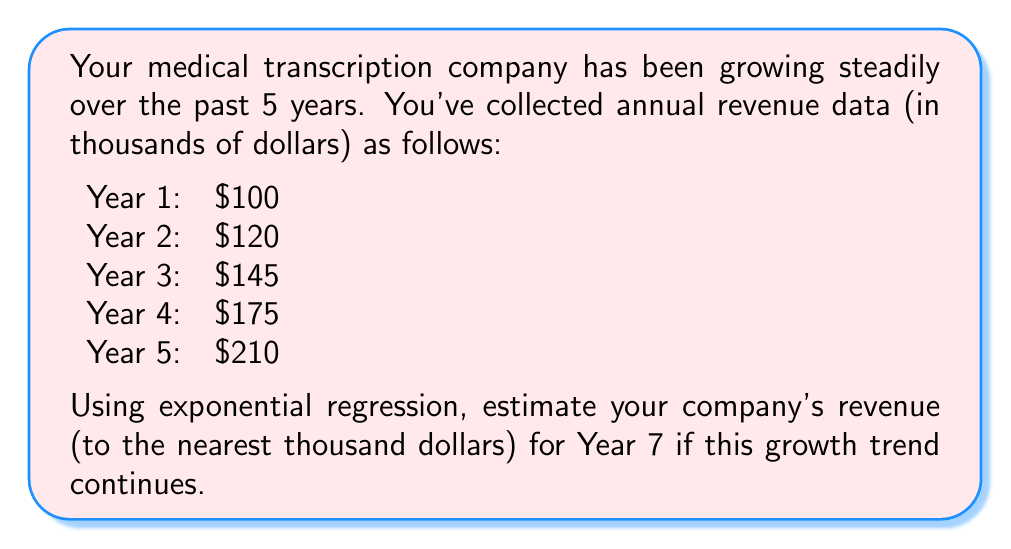Show me your answer to this math problem. To solve this problem using exponential regression, we'll follow these steps:

1) The exponential model for revenue growth is of the form $y = ae^{bx}$, where $y$ is the revenue, $x$ is the year, and $a$ and $b$ are constants we need to determine.

2) We can linearize this model by taking the natural logarithm of both sides:
   $\ln(y) = \ln(a) + bx$

3) Let $Y = \ln(y)$ and $A = \ln(a)$. Now we have a linear equation: $Y = A + bx$

4) We can use the following formulas to find $A$ and $b$:

   $b = \frac{n\sum(xY) - \sum x \sum Y}{n\sum x^2 - (\sum x)^2}$

   $A = \frac{\sum Y}{n} - b\frac{\sum x}{n}$

5) Let's create a table with our data:

   x | y | Y = ln(y) | x^2 | xY
   1 | 100 | 4.6052 | 1 | 4.6052
   2 | 120 | 4.7875 | 4 | 9.5750
   3 | 145 | 4.9767 | 9 | 14.9301
   4 | 175 | 5.1648 | 16 | 20.6592
   5 | 210 | 5.3471 | 25 | 26.7355

6) Now we can calculate:
   $\sum x = 15$, $\sum Y = 24.8813$, $\sum x^2 = 55$, $\sum xY = 76.5050$, $n = 5$

7) Plugging into our formulas:

   $b = \frac{5(76.5050) - 15(24.8813)}{5(55) - 15^2} = 0.1872$

   $A = \frac{24.8813}{5} - 0.1872(\frac{15}{5}) = 4.4139$

8) So our linearized model is $Y = 4.4139 + 0.1872x$

9) Converting back to the exponential form:
   $y = e^{4.4139} e^{0.1872x} = 82.6053e^{0.1872x}$

10) To estimate revenue for Year 7, we plug in $x = 7$:

    $y = 82.6053e^{0.1872(7)} = 302.8741$

11) Rounding to the nearest thousand:

    Estimated revenue for Year 7 ≈ $303,000
Answer: $303,000 